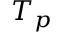<formula> <loc_0><loc_0><loc_500><loc_500>T _ { p }</formula> 